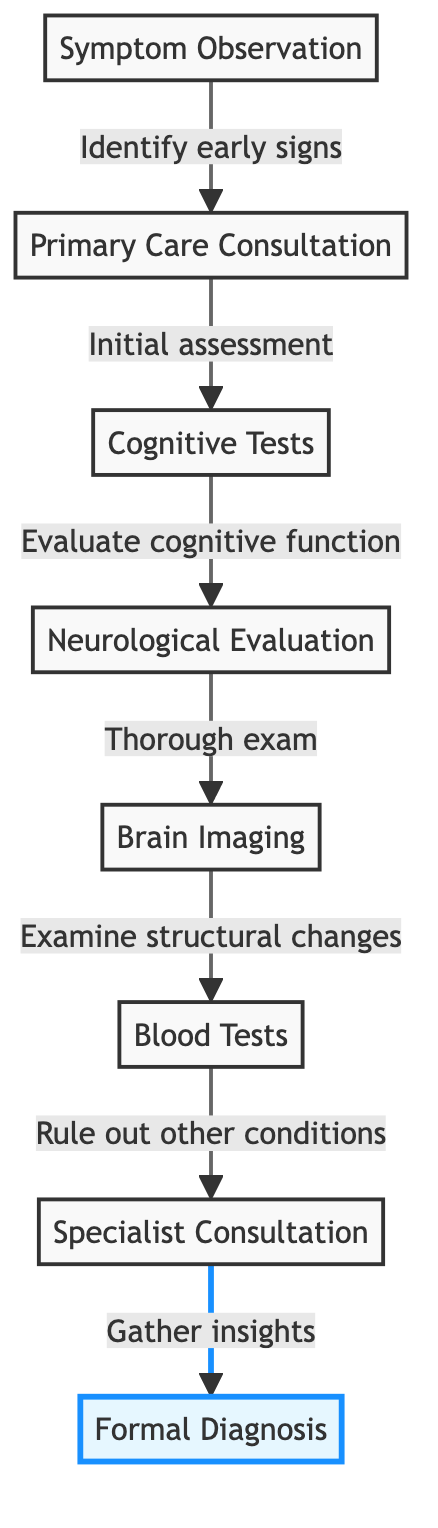What is the first step in the diagnosis process? The diagram shows that the first step is "Symptom Observation," which involves identifying early signs of dementia. This step initiates the diagnostic journey.
Answer: Symptom Observation How many total nodes are in the flowchart? The diagram presents a total of eight nodes, each representing a different step in the dementia diagnosis process. Counting each distinct step from symptom observation to formal diagnosis provides this total.
Answer: 8 What follows the "Primary Care Consultation" in the flowchart? The pathway after "Primary Care Consultation" leads to "Cognitive Tests." This indicates the sequence of steps that follow the initial consultation with a primary care physician.
Answer: Cognitive Tests Which step involves ruling out other conditions? The step that focuses on ruling out other conditions is "Blood Tests." This step is essential to ensure that symptoms are not due to other medical issues before confirming a diagnosis of dementia.
Answer: Blood Tests What is the final step in the flowchart? According to the diagram, the final step is "Formal Diagnosis." This confirms that the sequence culminates in receiving an official diagnosis based on previous assessments and evaluations.
Answer: Formal Diagnosis What is the relationship between "Cognitive Tests" and "Neurological Evaluation"? The relationship is sequential; "Cognitive Tests" is followed by "Neurological Evaluation," indicating that after cognitive assessments are done, a more thorough neurological exam is performed next.
Answer: Sequential relationship Which steps involve consultations with specialists? The steps that involve consultations with specialists are "Specialist Consultation" and "Primary Care Consultation." These steps highlight the importance of obtaining insights from medical professionals at various stages.
Answer: Specialist Consultation and Primary Care Consultation How do "Brain Imaging" and "Blood Tests" relate to the diagnostic process? Both "Brain Imaging" and "Blood Tests" are critical evaluation steps that follow "Neurological Evaluation." They help gather additional information needed to support a diagnosis by examining structural brain changes and ruling out other conditions, respectively.
Answer: Critical evaluation steps 